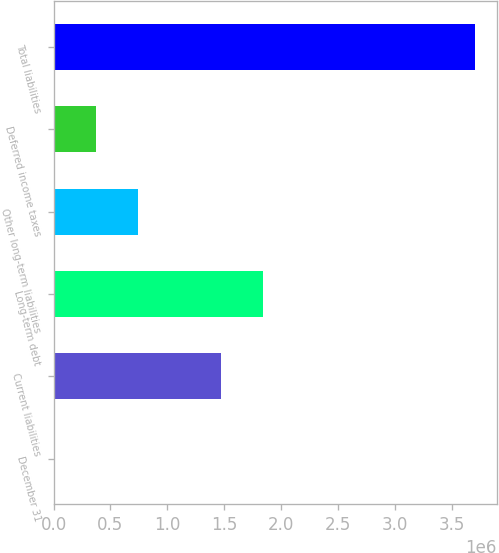Convert chart to OTSL. <chart><loc_0><loc_0><loc_500><loc_500><bar_chart><fcel>December 31<fcel>Current liabilities<fcel>Long-term debt<fcel>Other long-term liabilities<fcel>Deferred income taxes<fcel>Total liabilities<nl><fcel>2012<fcel>1.47111e+06<fcel>1.84156e+06<fcel>742903<fcel>372457<fcel>3.70647e+06<nl></chart> 